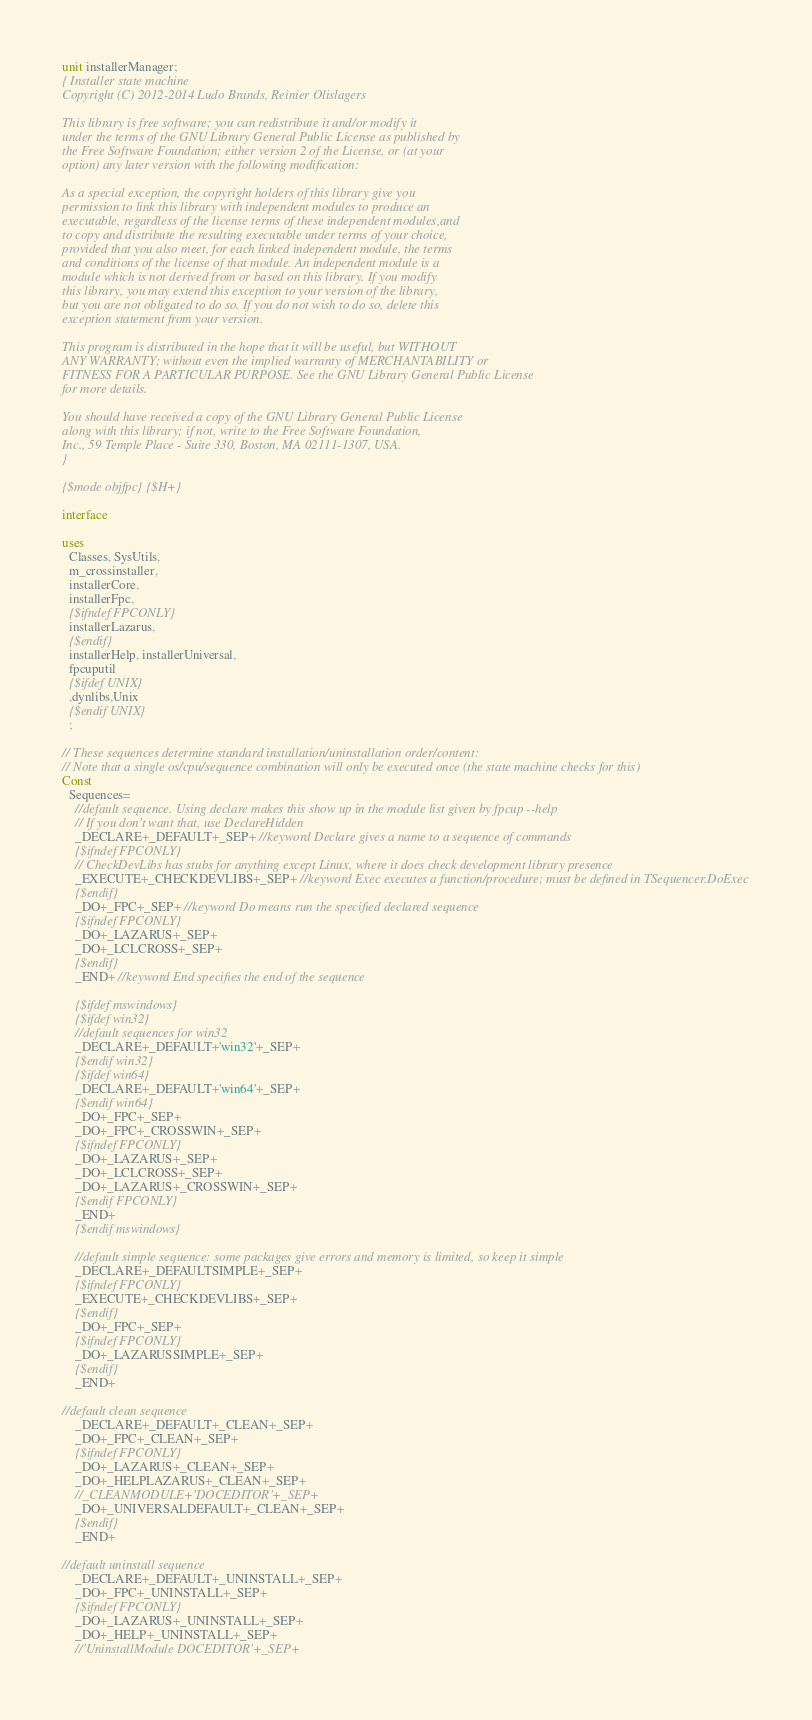<code> <loc_0><loc_0><loc_500><loc_500><_Pascal_>unit installerManager;
{ Installer state machine
Copyright (C) 2012-2014 Ludo Brands, Reinier Olislagers

This library is free software; you can redistribute it and/or modify it
under the terms of the GNU Library General Public License as published by
the Free Software Foundation; either version 2 of the License, or (at your
option) any later version with the following modification:

As a special exception, the copyright holders of this library give you
permission to link this library with independent modules to produce an
executable, regardless of the license terms of these independent modules,and
to copy and distribute the resulting executable under terms of your choice,
provided that you also meet, for each linked independent module, the terms
and conditions of the license of that module. An independent module is a
module which is not derived from or based on this library. If you modify
this library, you may extend this exception to your version of the library,
but you are not obligated to do so. If you do not wish to do so, delete this
exception statement from your version.

This program is distributed in the hope that it will be useful, but WITHOUT
ANY WARRANTY; without even the implied warranty of MERCHANTABILITY or
FITNESS FOR A PARTICULAR PURPOSE. See the GNU Library General Public License
for more details.

You should have received a copy of the GNU Library General Public License
along with this library; if not, write to the Free Software Foundation,
Inc., 59 Temple Place - Suite 330, Boston, MA 02111-1307, USA.
}

{$mode objfpc}{$H+}

interface

uses
  Classes, SysUtils,
  m_crossinstaller,
  installerCore,
  installerFpc,
  {$ifndef FPCONLY}
  installerLazarus,
  {$endif}
  installerHelp, installerUniversal,
  fpcuputil
  {$ifdef UNIX}
  ,dynlibs,Unix
  {$endif UNIX}
  ;

// These sequences determine standard installation/uninstallation order/content:
// Note that a single os/cpu/sequence combination will only be executed once (the state machine checks for this)
Const
  Sequences=
    //default sequence. Using declare makes this show up in the module list given by fpcup --help
    // If you don't want that, use DeclareHidden
    _DECLARE+_DEFAULT+_SEP+ //keyword Declare gives a name to a sequence of commands
    {$ifndef FPCONLY}
    // CheckDevLibs has stubs for anything except Linux, where it does check development library presence
    _EXECUTE+_CHECKDEVLIBS+_SEP+ //keyword Exec executes a function/procedure; must be defined in TSequencer.DoExec
    {$endif}
    _DO+_FPC+_SEP+ //keyword Do means run the specified declared sequence
    {$ifndef FPCONLY}
    _DO+_LAZARUS+_SEP+
    _DO+_LCLCROSS+_SEP+
    {$endif}
    _END+ //keyword End specifies the end of the sequence

    {$ifdef mswindows}
    {$ifdef win32}
    //default sequences for win32
    _DECLARE+_DEFAULT+'win32'+_SEP+
    {$endif win32}
    {$ifdef win64}
    _DECLARE+_DEFAULT+'win64'+_SEP+
    {$endif win64}
    _DO+_FPC+_SEP+
    _DO+_FPC+_CROSSWIN+_SEP+
    {$ifndef FPCONLY}
    _DO+_LAZARUS+_SEP+
    _DO+_LCLCROSS+_SEP+
    _DO+_LAZARUS+_CROSSWIN+_SEP+
    {$endif FPCONLY}
    _END+
    {$endif mswindows}

    //default simple sequence: some packages give errors and memory is limited, so keep it simple
    _DECLARE+_DEFAULTSIMPLE+_SEP+
    {$ifndef FPCONLY}
    _EXECUTE+_CHECKDEVLIBS+_SEP+
    {$endif}
    _DO+_FPC+_SEP+
    {$ifndef FPCONLY}
    _DO+_LAZARUSSIMPLE+_SEP+
    {$endif}
    _END+

//default clean sequence
    _DECLARE+_DEFAULT+_CLEAN+_SEP+
    _DO+_FPC+_CLEAN+_SEP+
    {$ifndef FPCONLY}
    _DO+_LAZARUS+_CLEAN+_SEP+
    _DO+_HELPLAZARUS+_CLEAN+_SEP+
    //_CLEANMODULE+'DOCEDITOR'+_SEP+
    _DO+_UNIVERSALDEFAULT+_CLEAN+_SEP+
    {$endif}
    _END+

//default uninstall sequence
    _DECLARE+_DEFAULT+_UNINSTALL+_SEP+
    _DO+_FPC+_UNINSTALL+_SEP+
    {$ifndef FPCONLY}
    _DO+_LAZARUS+_UNINSTALL+_SEP+
    _DO+_HELP+_UNINSTALL+_SEP+
    //'UninstallModule DOCEDITOR'+_SEP+</code> 